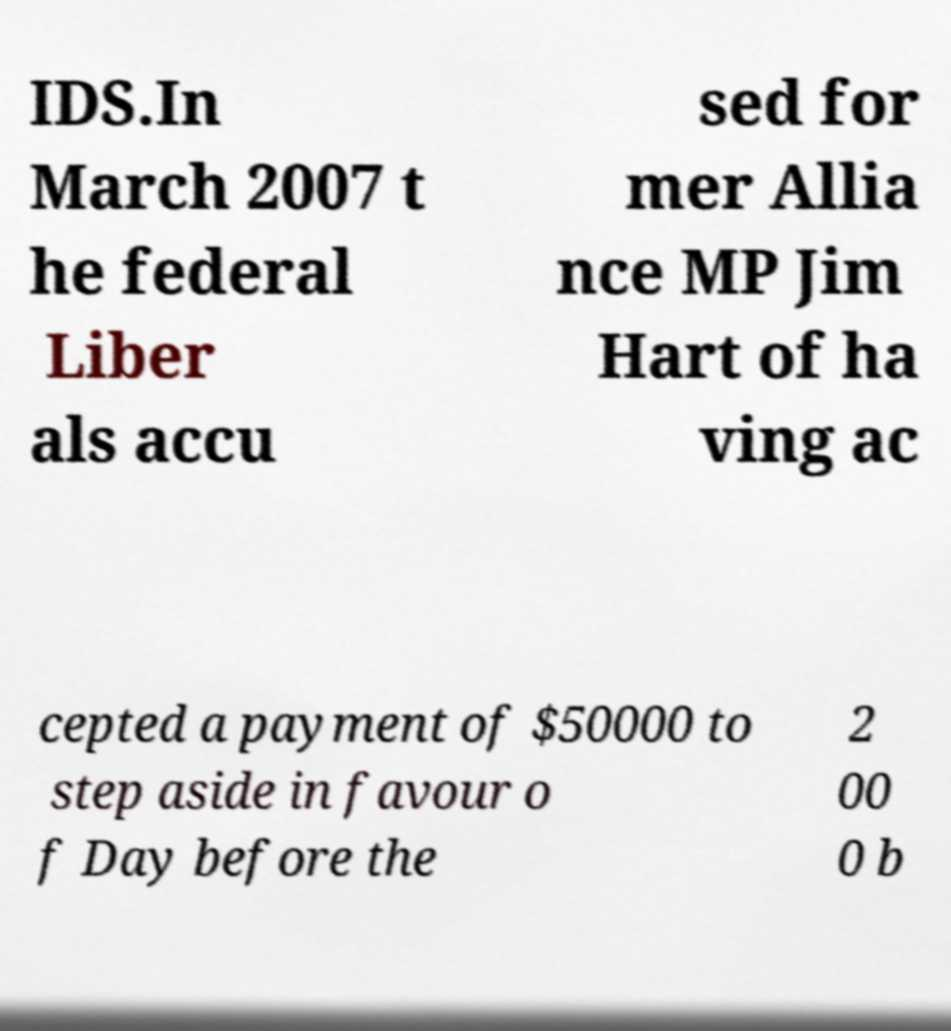I need the written content from this picture converted into text. Can you do that? IDS.In March 2007 t he federal Liber als accu sed for mer Allia nce MP Jim Hart of ha ving ac cepted a payment of $50000 to step aside in favour o f Day before the 2 00 0 b 